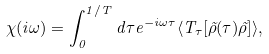<formula> <loc_0><loc_0><loc_500><loc_500>\chi ( i \omega ) = \int _ { 0 } ^ { 1 / T } d \tau e ^ { - i \omega \tau } \langle T _ { \tau } [ \tilde { \rho } ( \tau ) \tilde { \rho } ] \rangle ,</formula> 